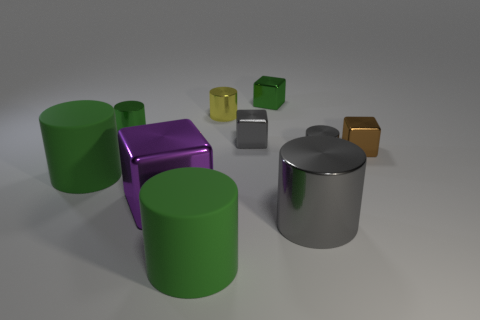How many green cylinders must be subtracted to get 1 green cylinders? 2 Subtract all large purple cubes. How many cubes are left? 3 Subtract all cubes. How many objects are left? 6 Subtract all purple blocks. How many blocks are left? 3 Add 2 purple metal cubes. How many purple metal cubes exist? 3 Subtract 0 cyan cylinders. How many objects are left? 10 Subtract 4 blocks. How many blocks are left? 0 Subtract all blue cubes. Subtract all red cylinders. How many cubes are left? 4 Subtract all yellow cylinders. How many green blocks are left? 1 Subtract all tiny brown metallic objects. Subtract all gray metallic objects. How many objects are left? 6 